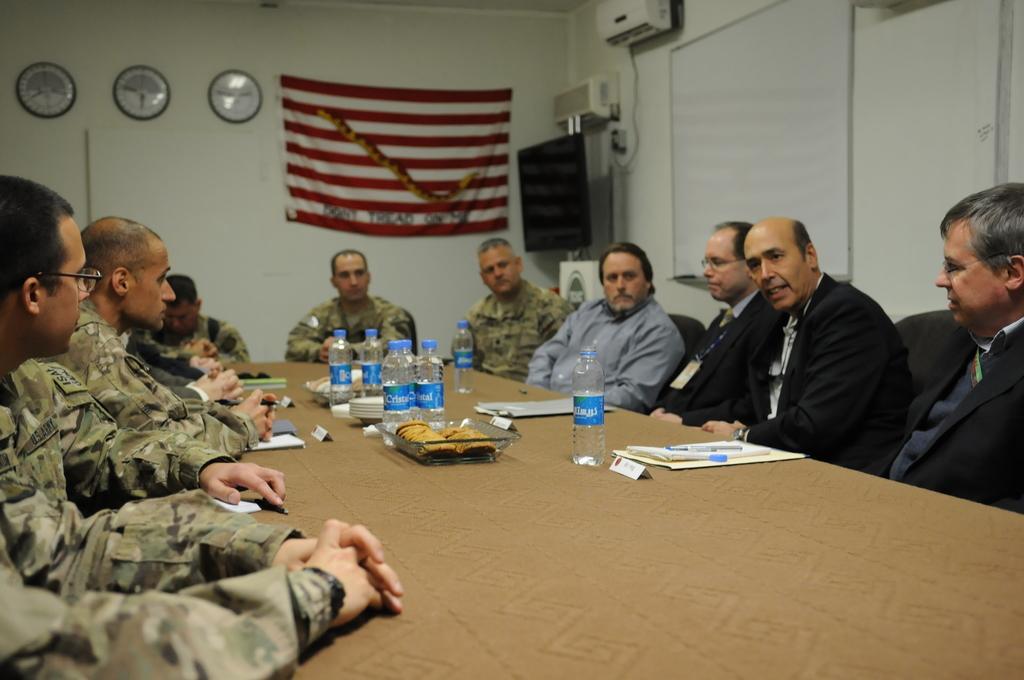Please provide a concise description of this image. In this image we can see a group of people sitting on the chairs. Here we can see a man on the right side is speaking. Here we can see the table on the floor. Here we can see a glass bowl, plates, water bottles and files are kept on the table. Here we can see the clocks and a flag on the wall. Here we can see the air conditioner on the wall. This is looking like a television. Here we can see the screen on the right side. 